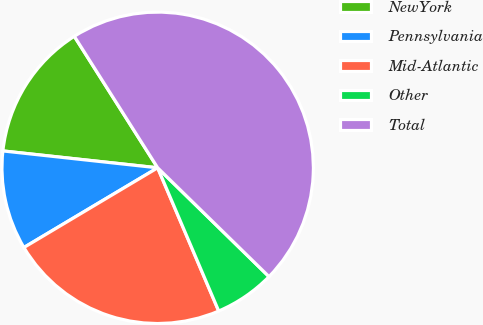Convert chart to OTSL. <chart><loc_0><loc_0><loc_500><loc_500><pie_chart><fcel>NewYork<fcel>Pennsylvania<fcel>Mid-Atlantic<fcel>Other<fcel>Total<nl><fcel>14.28%<fcel>10.28%<fcel>22.86%<fcel>6.27%<fcel>46.31%<nl></chart> 